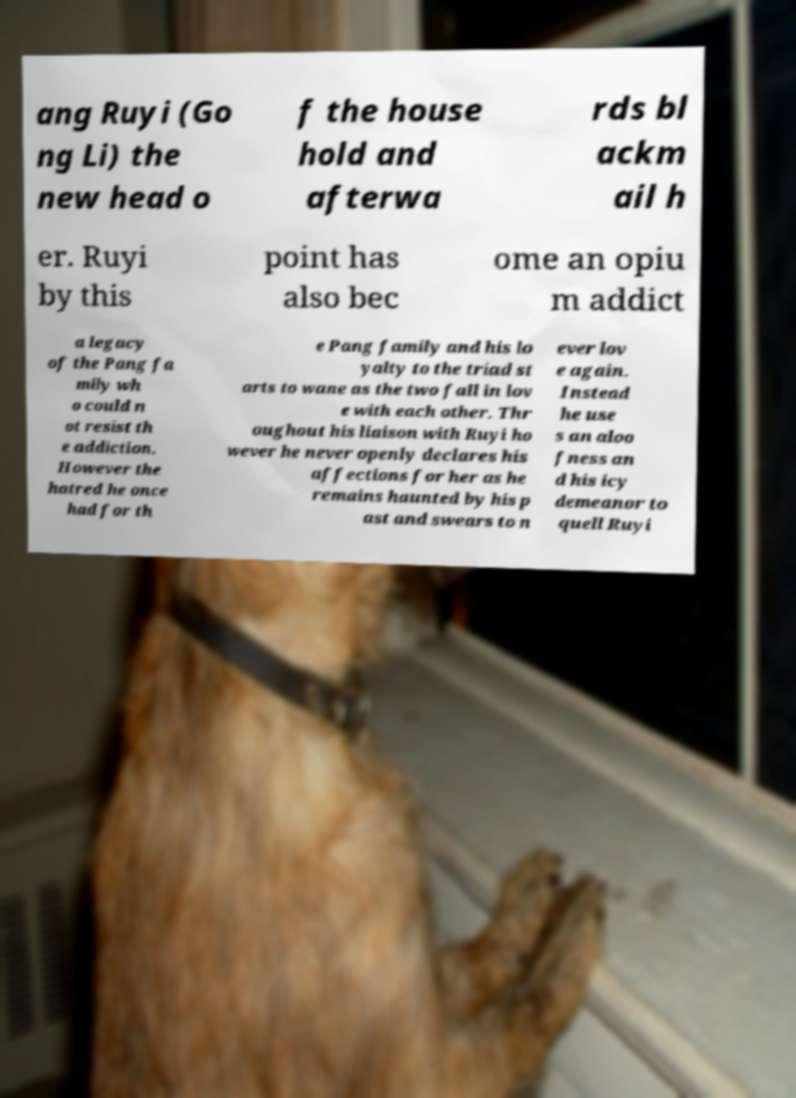Could you extract and type out the text from this image? ang Ruyi (Go ng Li) the new head o f the house hold and afterwa rds bl ackm ail h er. Ruyi by this point has also bec ome an opiu m addict a legacy of the Pang fa mily wh o could n ot resist th e addiction. However the hatred he once had for th e Pang family and his lo yalty to the triad st arts to wane as the two fall in lov e with each other. Thr oughout his liaison with Ruyi ho wever he never openly declares his affections for her as he remains haunted by his p ast and swears to n ever lov e again. Instead he use s an aloo fness an d his icy demeanor to quell Ruyi 